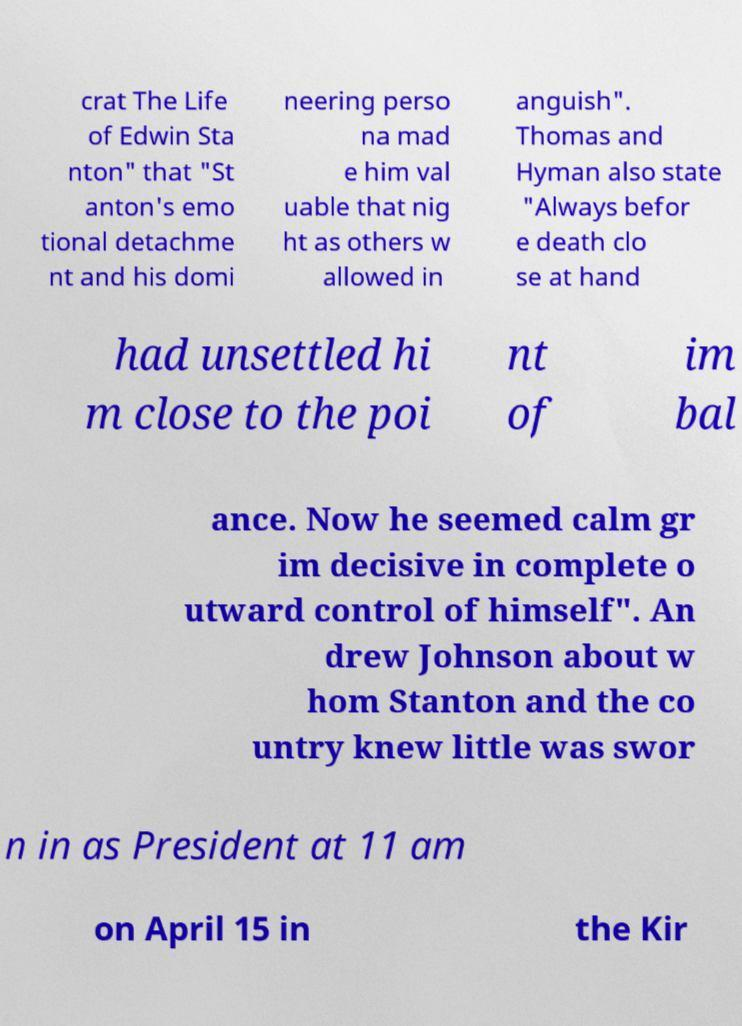There's text embedded in this image that I need extracted. Can you transcribe it verbatim? crat The Life of Edwin Sta nton" that "St anton's emo tional detachme nt and his domi neering perso na mad e him val uable that nig ht as others w allowed in anguish". Thomas and Hyman also state "Always befor e death clo se at hand had unsettled hi m close to the poi nt of im bal ance. Now he seemed calm gr im decisive in complete o utward control of himself". An drew Johnson about w hom Stanton and the co untry knew little was swor n in as President at 11 am on April 15 in the Kir 